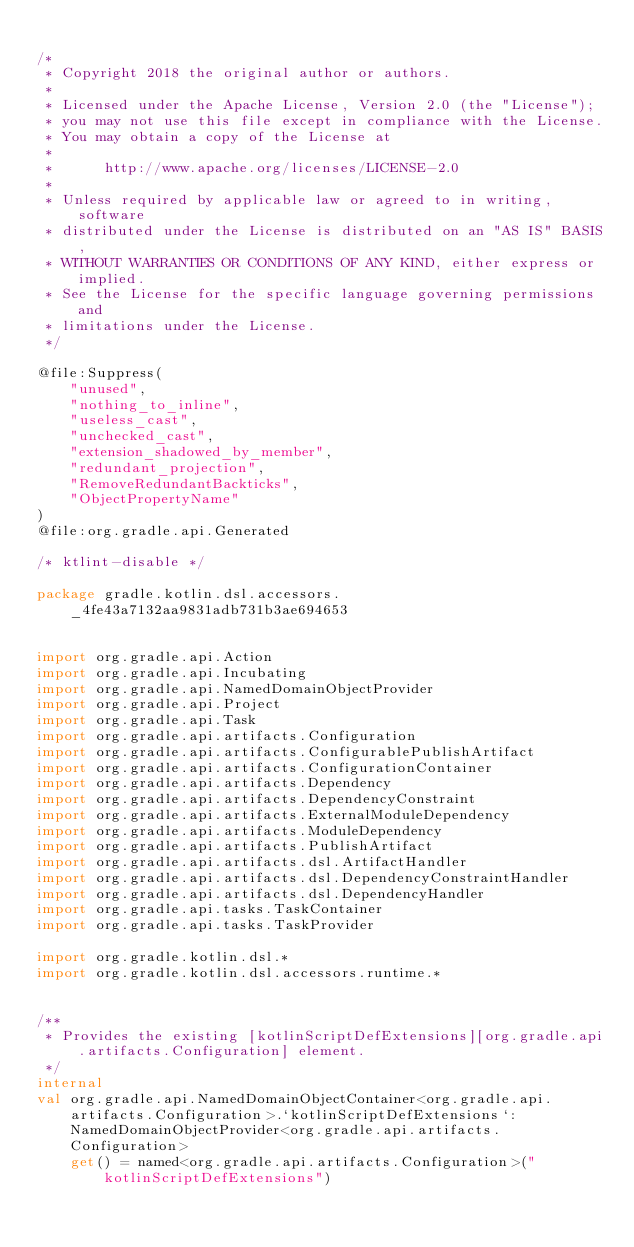<code> <loc_0><loc_0><loc_500><loc_500><_Kotlin_>
/*
 * Copyright 2018 the original author or authors.
 *
 * Licensed under the Apache License, Version 2.0 (the "License");
 * you may not use this file except in compliance with the License.
 * You may obtain a copy of the License at
 *
 *      http://www.apache.org/licenses/LICENSE-2.0
 *
 * Unless required by applicable law or agreed to in writing, software
 * distributed under the License is distributed on an "AS IS" BASIS,
 * WITHOUT WARRANTIES OR CONDITIONS OF ANY KIND, either express or implied.
 * See the License for the specific language governing permissions and
 * limitations under the License.
 */

@file:Suppress(
    "unused",
    "nothing_to_inline",
    "useless_cast",
    "unchecked_cast",
    "extension_shadowed_by_member",
    "redundant_projection",
    "RemoveRedundantBackticks",
    "ObjectPropertyName"
)
@file:org.gradle.api.Generated

/* ktlint-disable */

package gradle.kotlin.dsl.accessors._4fe43a7132aa9831adb731b3ae694653


import org.gradle.api.Action
import org.gradle.api.Incubating
import org.gradle.api.NamedDomainObjectProvider
import org.gradle.api.Project
import org.gradle.api.Task
import org.gradle.api.artifacts.Configuration
import org.gradle.api.artifacts.ConfigurablePublishArtifact
import org.gradle.api.artifacts.ConfigurationContainer
import org.gradle.api.artifacts.Dependency
import org.gradle.api.artifacts.DependencyConstraint
import org.gradle.api.artifacts.ExternalModuleDependency
import org.gradle.api.artifacts.ModuleDependency
import org.gradle.api.artifacts.PublishArtifact
import org.gradle.api.artifacts.dsl.ArtifactHandler
import org.gradle.api.artifacts.dsl.DependencyConstraintHandler
import org.gradle.api.artifacts.dsl.DependencyHandler
import org.gradle.api.tasks.TaskContainer
import org.gradle.api.tasks.TaskProvider

import org.gradle.kotlin.dsl.*
import org.gradle.kotlin.dsl.accessors.runtime.*


/**
 * Provides the existing [kotlinScriptDefExtensions][org.gradle.api.artifacts.Configuration] element.
 */
internal
val org.gradle.api.NamedDomainObjectContainer<org.gradle.api.artifacts.Configuration>.`kotlinScriptDefExtensions`: NamedDomainObjectProvider<org.gradle.api.artifacts.Configuration>
    get() = named<org.gradle.api.artifacts.Configuration>("kotlinScriptDefExtensions")


</code> 